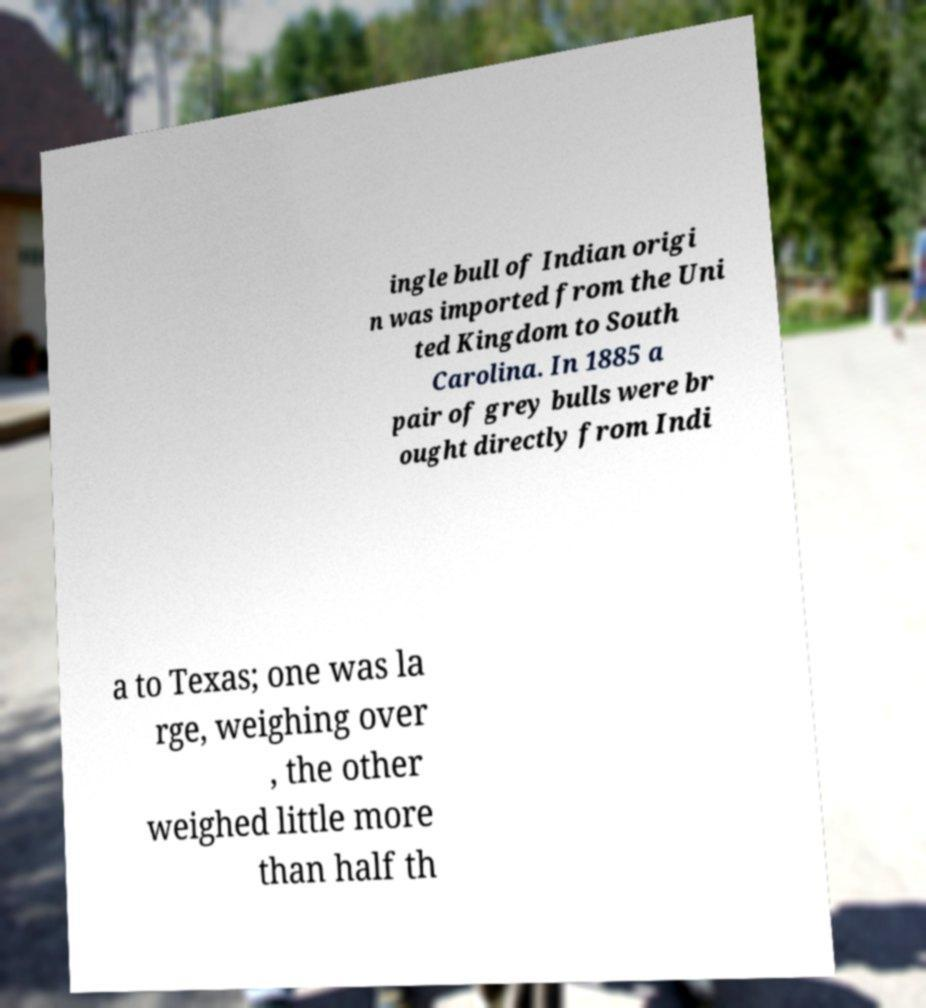Can you read and provide the text displayed in the image?This photo seems to have some interesting text. Can you extract and type it out for me? ingle bull of Indian origi n was imported from the Uni ted Kingdom to South Carolina. In 1885 a pair of grey bulls were br ought directly from Indi a to Texas; one was la rge, weighing over , the other weighed little more than half th 